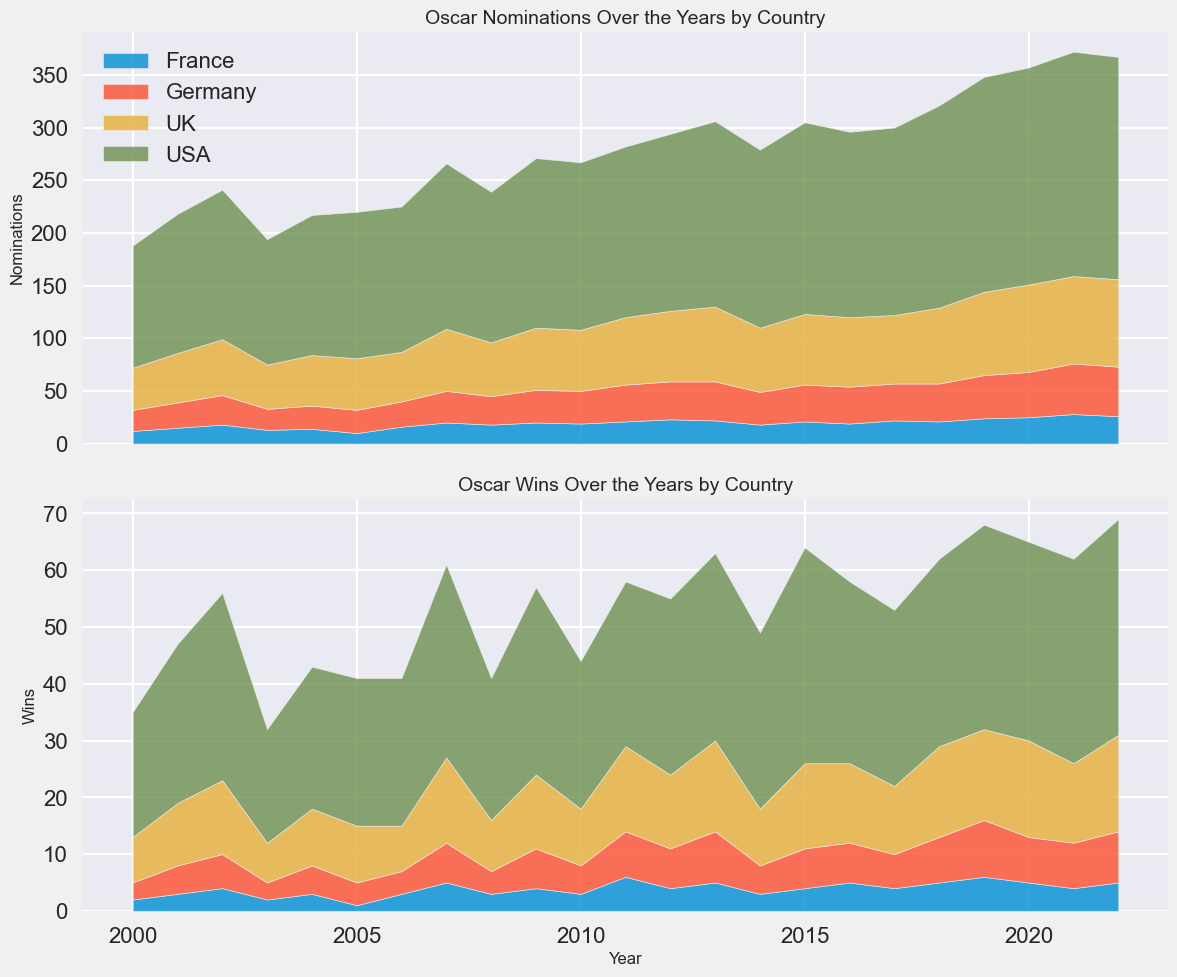How has the total number of Oscar nominations for the USA changed from 2000 to 2022? In the top panel of the figure, locate the USA area and compare its height in 2000 and 2022. The height in 2000 is much lower compared to 2022.
Answer: Increased Which country had the most Oscar wins in 2011? In the bottom panel of the figure, locate the year 2011 and compare the heights of the areas for USA, UK, France, and Germany. The USA has the tallest area.
Answer: USA Between 2000 and 2022, which country showed the most consistent year-to-year increase in Oscar wins? In the bottom panel of the figure, observe the smoothness and consistency of the area increases for each country. The USA has a more consistent increase than others.
Answer: USA In which year did the UK achieve its highest number of Oscar nominations? In the top panel of the figure, locate the peak height of the UK area. This occurs around 2020.
Answer: 2020 Which country had a more variable number of Oscar wins from year to year, France or Germany? In the bottom panel of the figure, compare the fluctuation in the heights of the areas for France and Germany. France has more peaks and troughs, indicating higher variability.
Answer: France Did the USA achieve more Oscar wins or nominations in 2015? In the top panel of the figure, locate the year 2015 and check the height for nominations. Then do the same in the bottom panel for wins. Nominations are higher than wins.
Answer: Nominations How many Oscar wins did France have in 2021? In the bottom panel of the figure, locate the year 2021 and examine the height of the France area. The height is consistent with the number 4.
Answer: 4 Which country had the highest combined number of Oscar wins and nominations in 2022? Sum the heights of the areas for wins and nominations in 2022 for each country. The USA has the tallest combined height.
Answer: USA By how much did the UK’s Oscar nominations increase from 2000 to 2012? In the top panel of the figure, locate the height of the UK area in 2000 and 2012 and find their difference. From 20 in 2000 to 31 in 2012, the increase is 11.
Answer: 11 Compare the overall trend for Germany's Oscar nominations and wins from 2000 to 2022. Are they similar? In both panels of the figure, observe the growth patterns of Germany’s areas. The trends for nominations and wins are both increasing but more steadily for nominations.
Answer: Yes, similar 